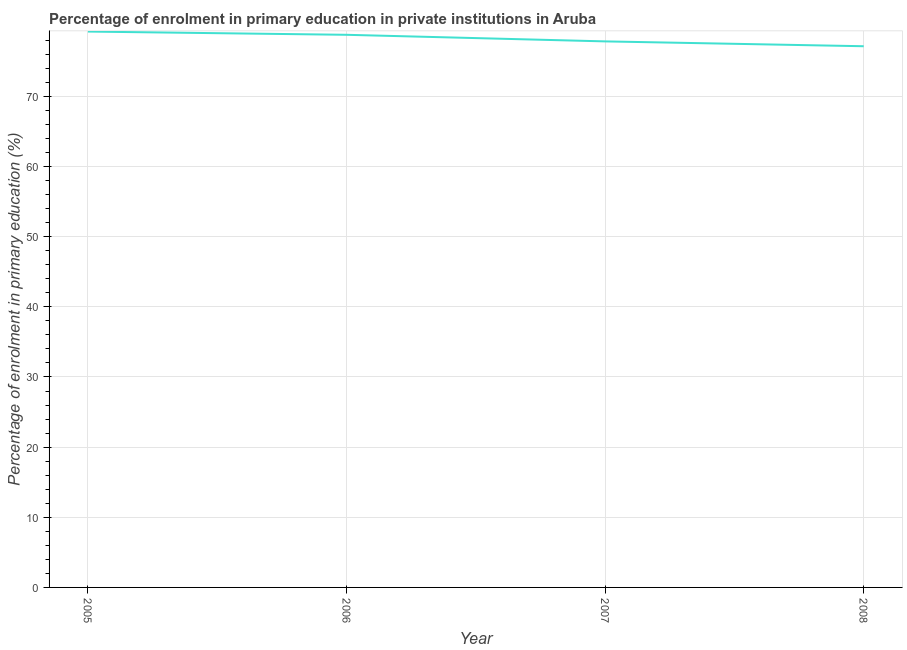What is the enrolment percentage in primary education in 2007?
Make the answer very short. 77.85. Across all years, what is the maximum enrolment percentage in primary education?
Your answer should be compact. 79.25. Across all years, what is the minimum enrolment percentage in primary education?
Your response must be concise. 77.16. In which year was the enrolment percentage in primary education maximum?
Offer a terse response. 2005. In which year was the enrolment percentage in primary education minimum?
Offer a very short reply. 2008. What is the sum of the enrolment percentage in primary education?
Offer a terse response. 313.04. What is the difference between the enrolment percentage in primary education in 2005 and 2006?
Provide a succinct answer. 0.46. What is the average enrolment percentage in primary education per year?
Offer a terse response. 78.26. What is the median enrolment percentage in primary education?
Ensure brevity in your answer.  78.32. In how many years, is the enrolment percentage in primary education greater than 72 %?
Keep it short and to the point. 4. Do a majority of the years between 2006 and 2007 (inclusive) have enrolment percentage in primary education greater than 60 %?
Provide a succinct answer. Yes. What is the ratio of the enrolment percentage in primary education in 2007 to that in 2008?
Make the answer very short. 1.01. Is the difference between the enrolment percentage in primary education in 2006 and 2008 greater than the difference between any two years?
Make the answer very short. No. What is the difference between the highest and the second highest enrolment percentage in primary education?
Your answer should be compact. 0.46. What is the difference between the highest and the lowest enrolment percentage in primary education?
Offer a terse response. 2.09. In how many years, is the enrolment percentage in primary education greater than the average enrolment percentage in primary education taken over all years?
Your answer should be very brief. 2. How many lines are there?
Your answer should be very brief. 1. How many years are there in the graph?
Make the answer very short. 4. Does the graph contain any zero values?
Your answer should be compact. No. Does the graph contain grids?
Provide a short and direct response. Yes. What is the title of the graph?
Your answer should be very brief. Percentage of enrolment in primary education in private institutions in Aruba. What is the label or title of the Y-axis?
Your answer should be compact. Percentage of enrolment in primary education (%). What is the Percentage of enrolment in primary education (%) in 2005?
Your response must be concise. 79.25. What is the Percentage of enrolment in primary education (%) of 2006?
Offer a terse response. 78.79. What is the Percentage of enrolment in primary education (%) in 2007?
Give a very brief answer. 77.85. What is the Percentage of enrolment in primary education (%) of 2008?
Offer a very short reply. 77.16. What is the difference between the Percentage of enrolment in primary education (%) in 2005 and 2006?
Offer a terse response. 0.46. What is the difference between the Percentage of enrolment in primary education (%) in 2005 and 2007?
Offer a terse response. 1.4. What is the difference between the Percentage of enrolment in primary education (%) in 2005 and 2008?
Give a very brief answer. 2.09. What is the difference between the Percentage of enrolment in primary education (%) in 2006 and 2007?
Keep it short and to the point. 0.94. What is the difference between the Percentage of enrolment in primary education (%) in 2006 and 2008?
Provide a succinct answer. 1.63. What is the difference between the Percentage of enrolment in primary education (%) in 2007 and 2008?
Provide a short and direct response. 0.69. What is the ratio of the Percentage of enrolment in primary education (%) in 2005 to that in 2007?
Keep it short and to the point. 1.02. What is the ratio of the Percentage of enrolment in primary education (%) in 2006 to that in 2007?
Give a very brief answer. 1.01. What is the ratio of the Percentage of enrolment in primary education (%) in 2006 to that in 2008?
Your answer should be very brief. 1.02. What is the ratio of the Percentage of enrolment in primary education (%) in 2007 to that in 2008?
Ensure brevity in your answer.  1.01. 